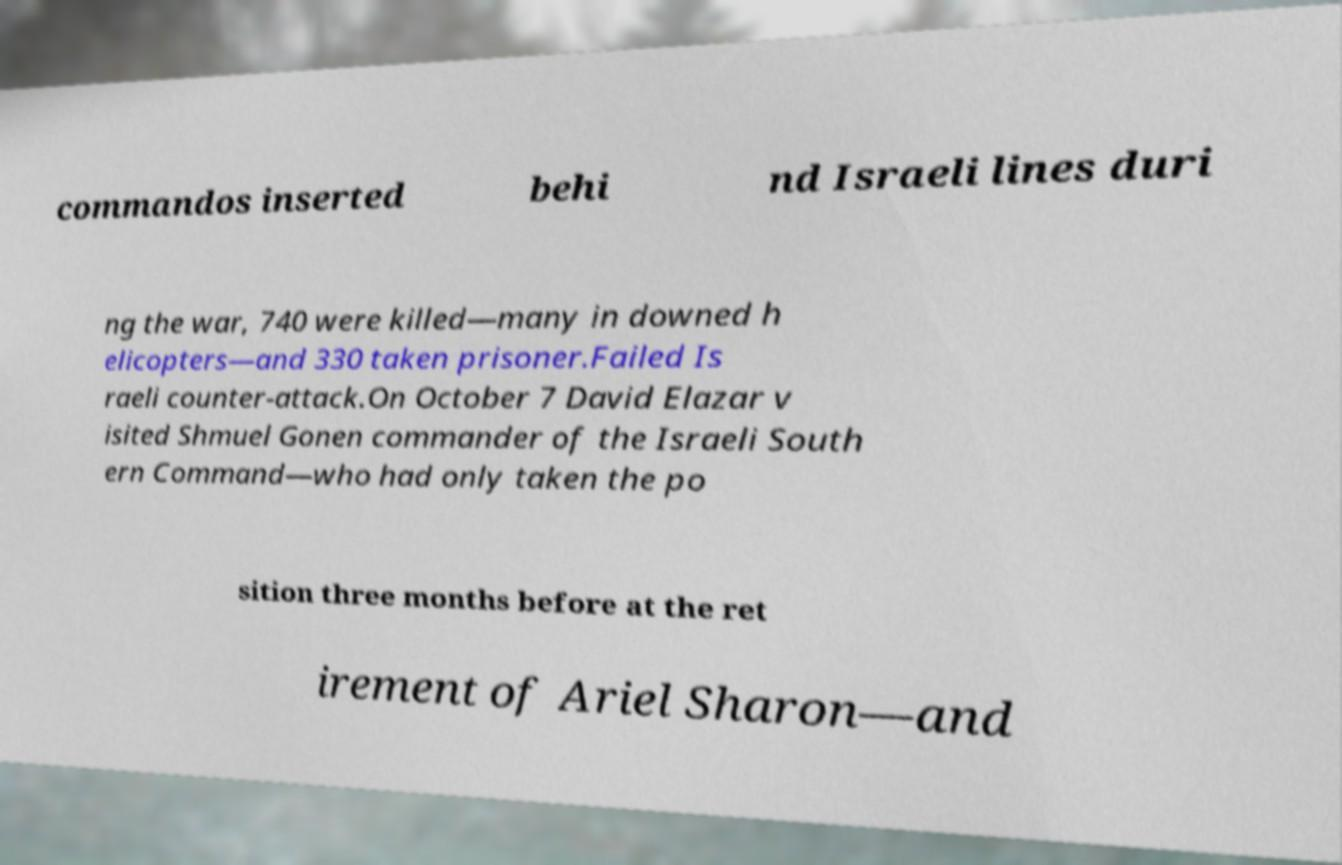Can you accurately transcribe the text from the provided image for me? commandos inserted behi nd Israeli lines duri ng the war, 740 were killed—many in downed h elicopters—and 330 taken prisoner.Failed Is raeli counter-attack.On October 7 David Elazar v isited Shmuel Gonen commander of the Israeli South ern Command—who had only taken the po sition three months before at the ret irement of Ariel Sharon—and 